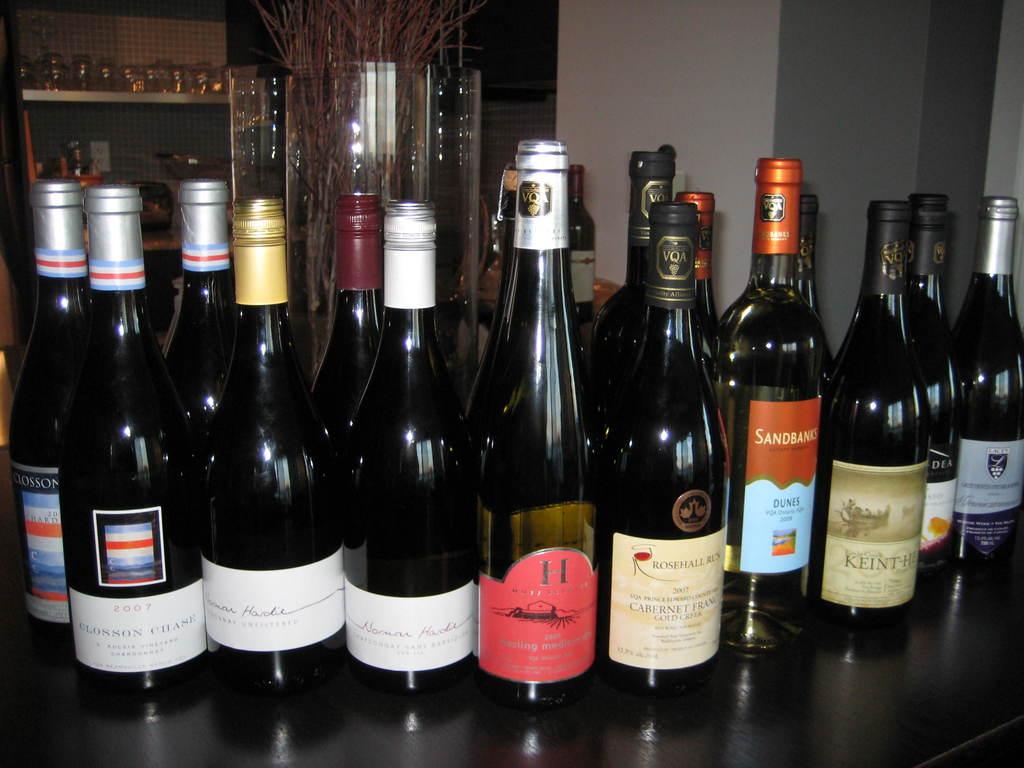What is the year on the second to the left bottle?
Your answer should be very brief. 2007. 